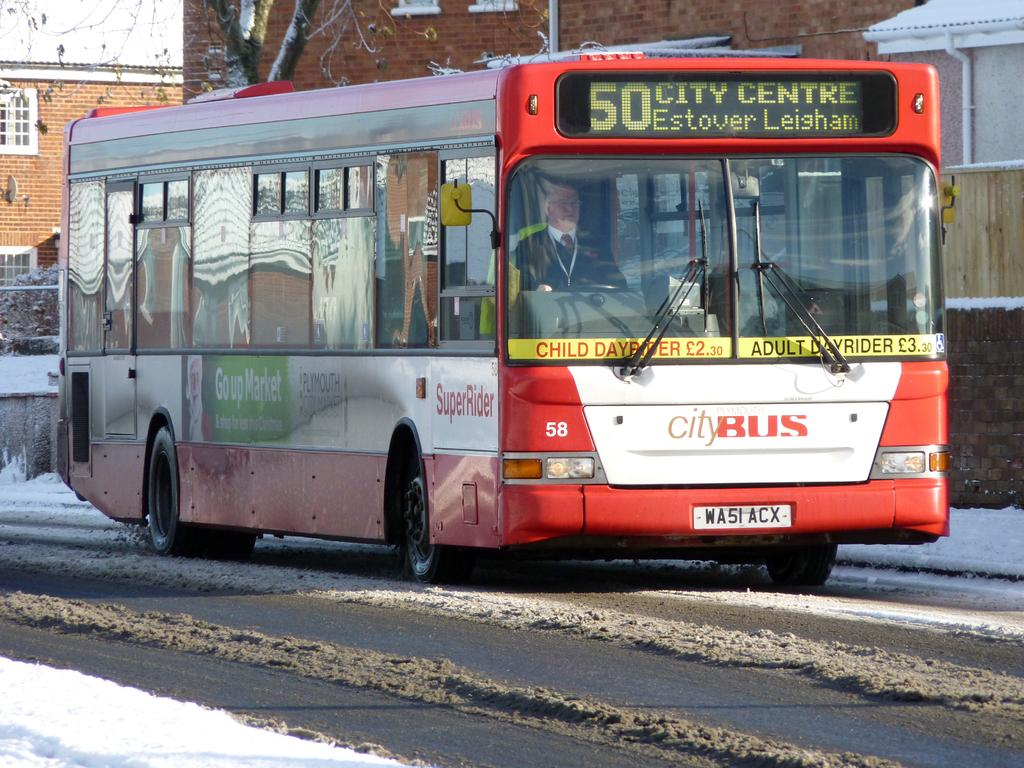What is the person in the image doing? There is a person riding a bus in the image. Where is the bus located? The bus is on the road. What can be seen in the background of the image? There are buildings, windows, a tree, poles, and the sky visible in the background of the image. What type of vegetation is present in the background? Plants are present in the background of the image. What is the condition of the road in the image? Snow is visible on the road in the image. What type of drink is the person holding in the image? There is no drink visible in the image; the person is riding a bus. What part of the brain can be seen in the image? There is no brain visible in the image; it is a picture of a person riding a bus on a snowy road. 